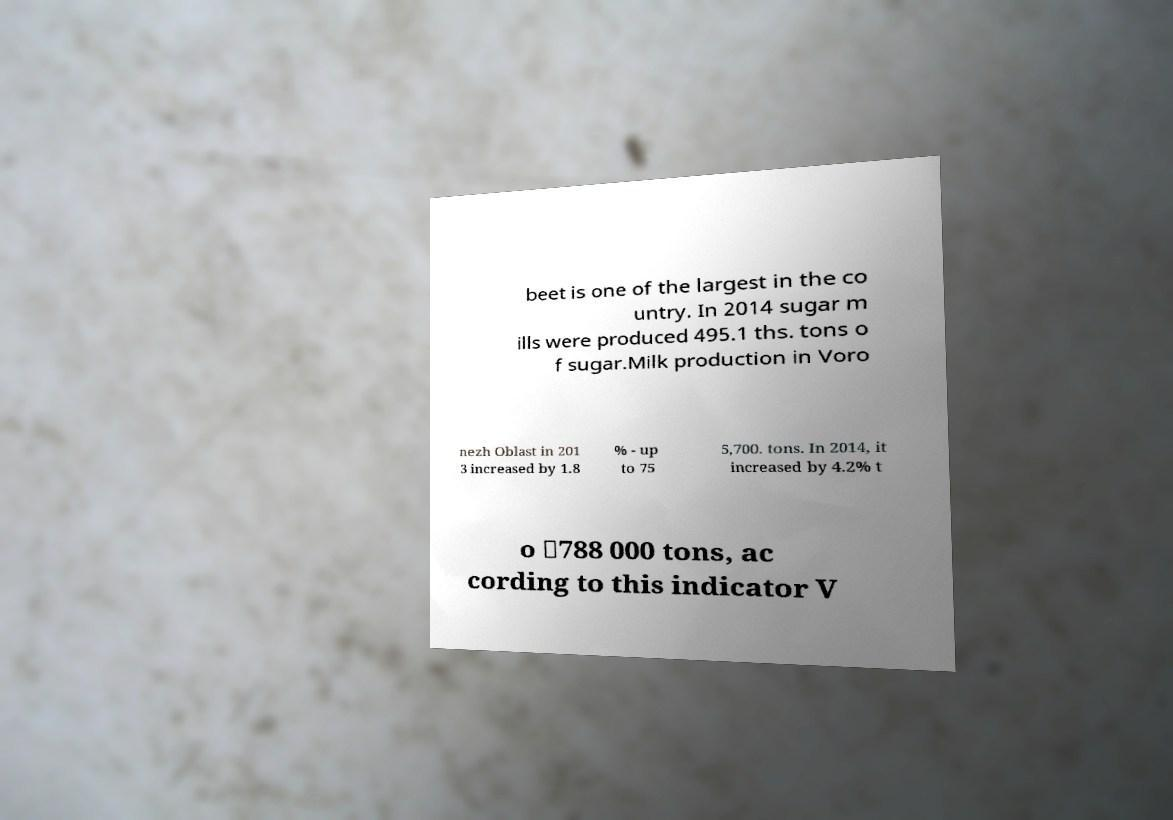Could you assist in decoding the text presented in this image and type it out clearly? beet is one of the largest in the co untry. In 2014 sugar m ills were produced 495.1 ths. tons o f sugar.Milk production in Voro nezh Oblast in 201 3 increased by 1.8 % - up to 75 5,700. tons. In 2014, it increased by 4.2% t o ↗788 000 tons, ac cording to this indicator V 